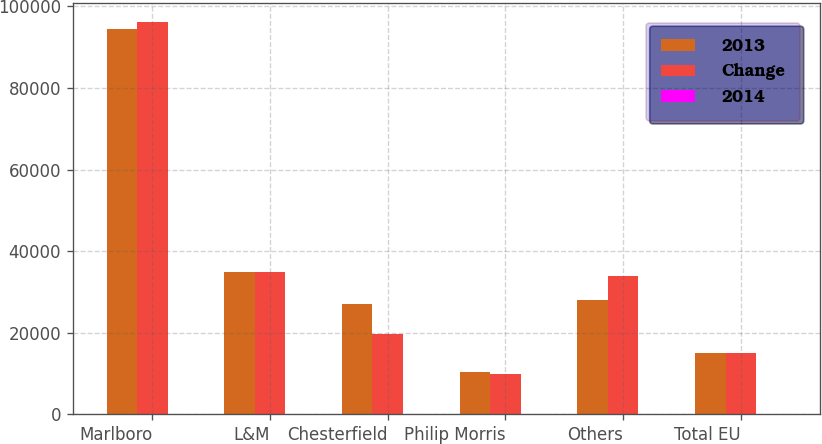Convert chart. <chart><loc_0><loc_0><loc_500><loc_500><stacked_bar_chart><ecel><fcel>Marlboro<fcel>L&M<fcel>Chesterfield<fcel>Philip Morris<fcel>Others<fcel>Total EU<nl><fcel>2013<fcel>94537<fcel>34943<fcel>27100<fcel>10224<fcel>27942<fcel>14965.5<nl><fcel>Change<fcel>96069<fcel>34985<fcel>19707<fcel>9768<fcel>33935<fcel>14965.5<nl><fcel>2014<fcel>1.6<fcel>0.1<fcel>37.5<fcel>4.7<fcel>17.7<fcel>0.1<nl></chart> 